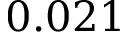<formula> <loc_0><loc_0><loc_500><loc_500>0 . 0 2 1</formula> 